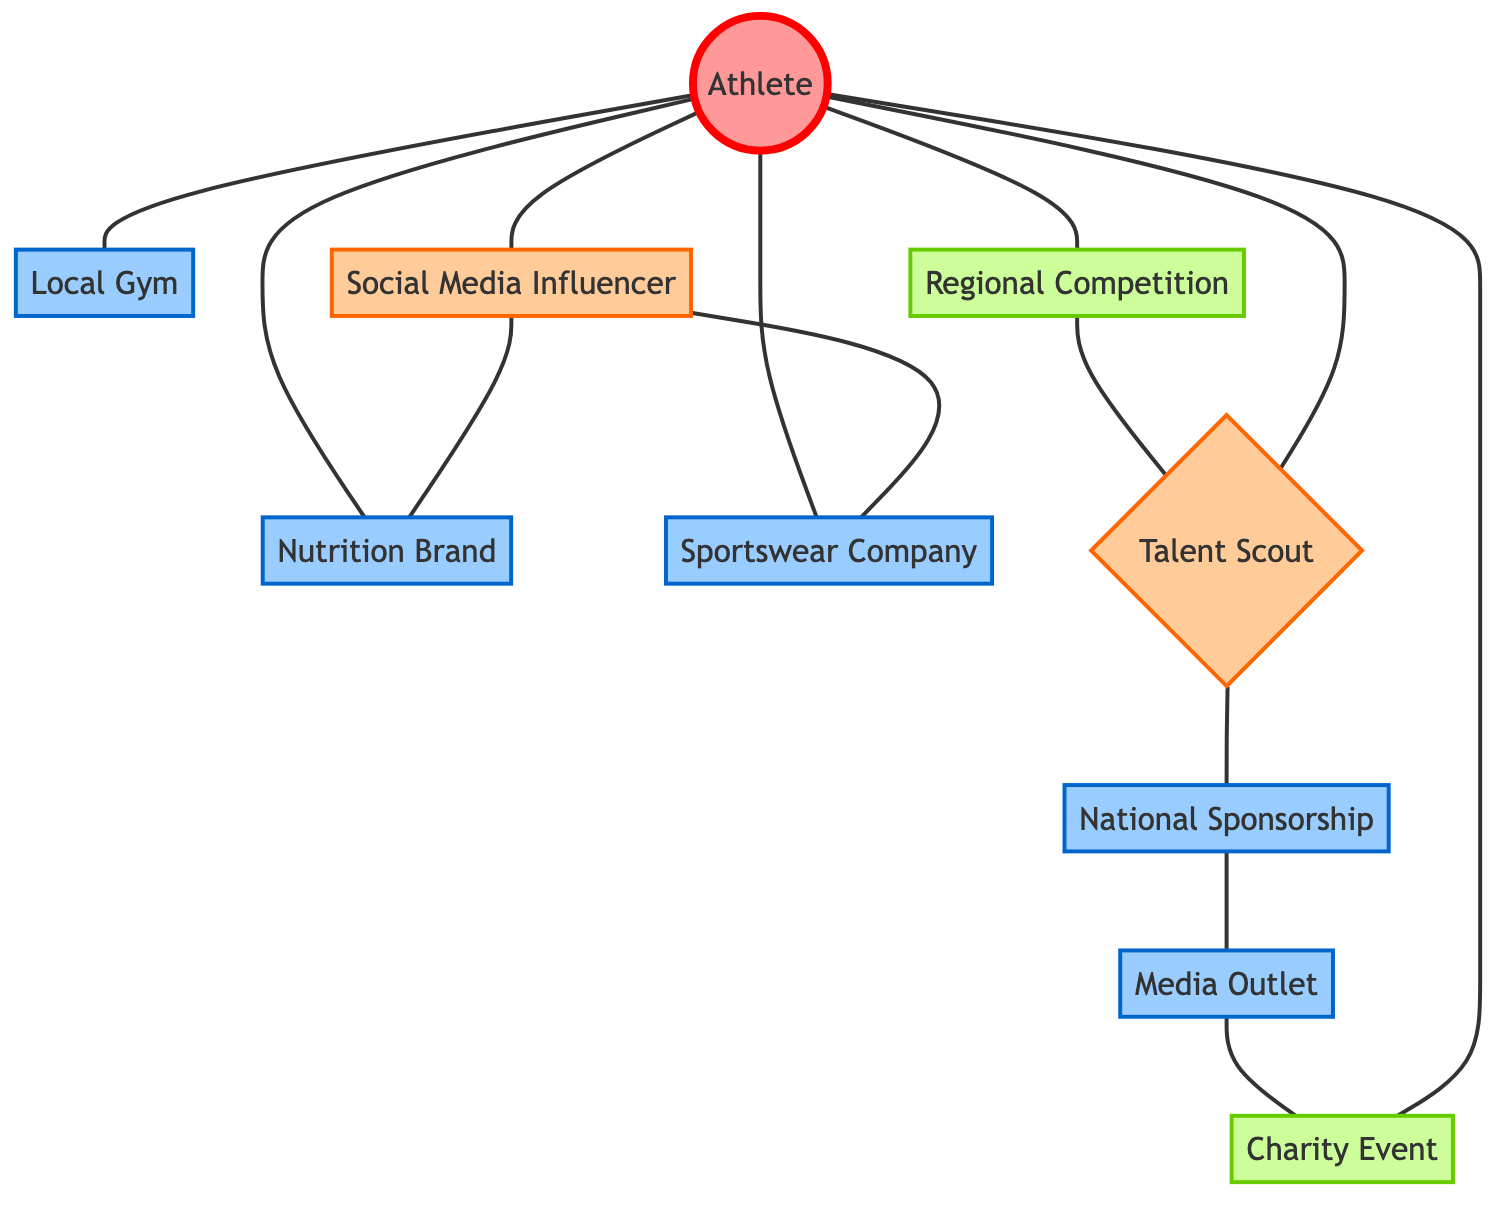What node is directly connected to the athlete node? The athlete node is directly connected to several nodes including local gym, nutrition brand, sportswear company, regional competition, talent scout, and social media influencer. Since the question asks for any one of those nodes, we can name any.
Answer: local gym How many nodes are in the diagram? To find the total number of nodes, we simply count the distinct entities represented. There are 10 nodes listed in the data: athlete, local gym, nutrition brand, sportswear company, regional competition, talent scout, social media influencer, national sponsorship, media outlet, and charity event.
Answer: 10 Which node serves as a bridge between the talent scout and the media outlet? The talent scout is connected to the national sponsorship, which in turn is connected to the media outlet. Thus, national sponsorship acts as a bridge between these two nodes.
Answer: national sponsorship What are the edges connected to the nutrition brand node? The nutrition brand node has three edges connected. It is directly connected to the athlete node and indirectly connected to the athlete via the social media influencer, which also connects to the nutrition brand. Additionally, the connection with social media influencer indicates a flow back.
Answer: 3 How many connections does the athlete node have? By counting the edges that directly connect to the athlete node, we see it has 6 connections: local gym, nutrition brand, sportswear company, regional competition, talent scout, and social media influencer.
Answer: 6 What is the relationship between the charity event and the athlete node? The charity event node has a direct edge that connects it back to the athlete node, indicating a direct relationship or participation between the athlete and the charity event.
Answer: direct connection Who influences the nutrition brand in the network? The nutrition brand is influenced by both the athlete and the social media influencer, with the latter having a direct edge connecting it to the nutrition brand.
Answer: social media influencer Which node is indirectly connected to regional competition through two steps? The node that is indirectly connected to regional competition through two steps is the media outlet. The path is regional competition to talent scout to national sponsorship to media outlet.
Answer: media outlet What type of event is the charity event node classified as? According to the classifications in the diagram, the charity event is categorized under "event". It has the associated styling specific to events in the visualization.
Answer: event 